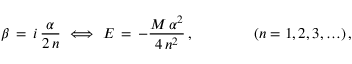Convert formula to latex. <formula><loc_0><loc_0><loc_500><loc_500>\beta \, = \, i \, \frac { \alpha } { 2 \, n } \, \Longleftrightarrow \, E \, = \, - \frac { M \, \alpha ^ { 2 } } { 4 \, n ^ { 2 } } \, , \quad ( n = 1 , 2 , 3 , \dots ) \, ,</formula> 